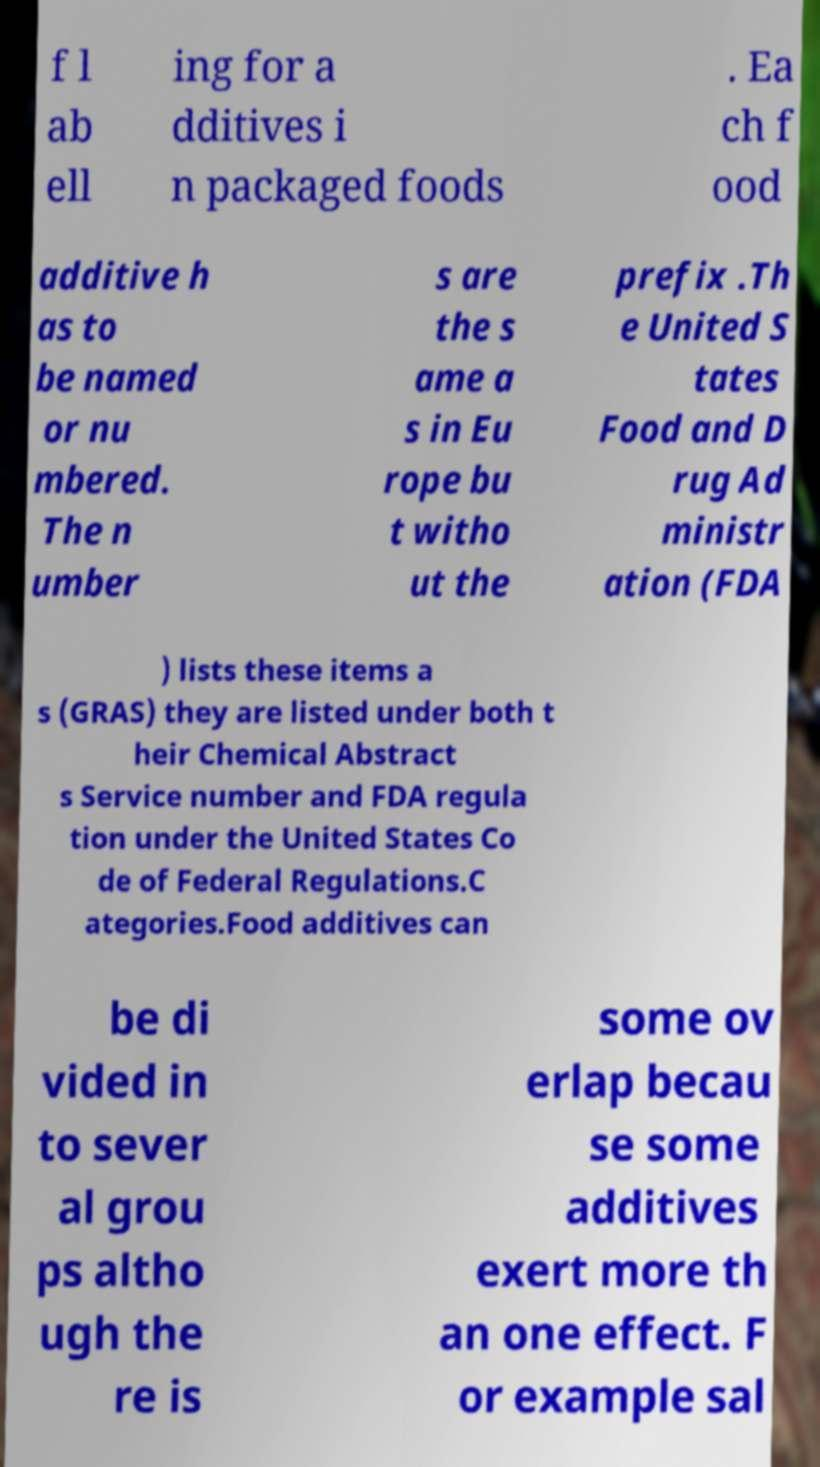Could you extract and type out the text from this image? f l ab ell ing for a dditives i n packaged foods . Ea ch f ood additive h as to be named or nu mbered. The n umber s are the s ame a s in Eu rope bu t witho ut the prefix .Th e United S tates Food and D rug Ad ministr ation (FDA ) lists these items a s (GRAS) they are listed under both t heir Chemical Abstract s Service number and FDA regula tion under the United States Co de of Federal Regulations.C ategories.Food additives can be di vided in to sever al grou ps altho ugh the re is some ov erlap becau se some additives exert more th an one effect. F or example sal 